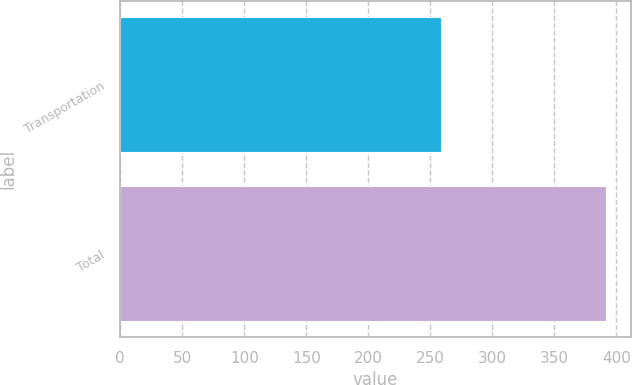Convert chart. <chart><loc_0><loc_0><loc_500><loc_500><bar_chart><fcel>Transportation<fcel>Total<nl><fcel>259<fcel>392<nl></chart> 